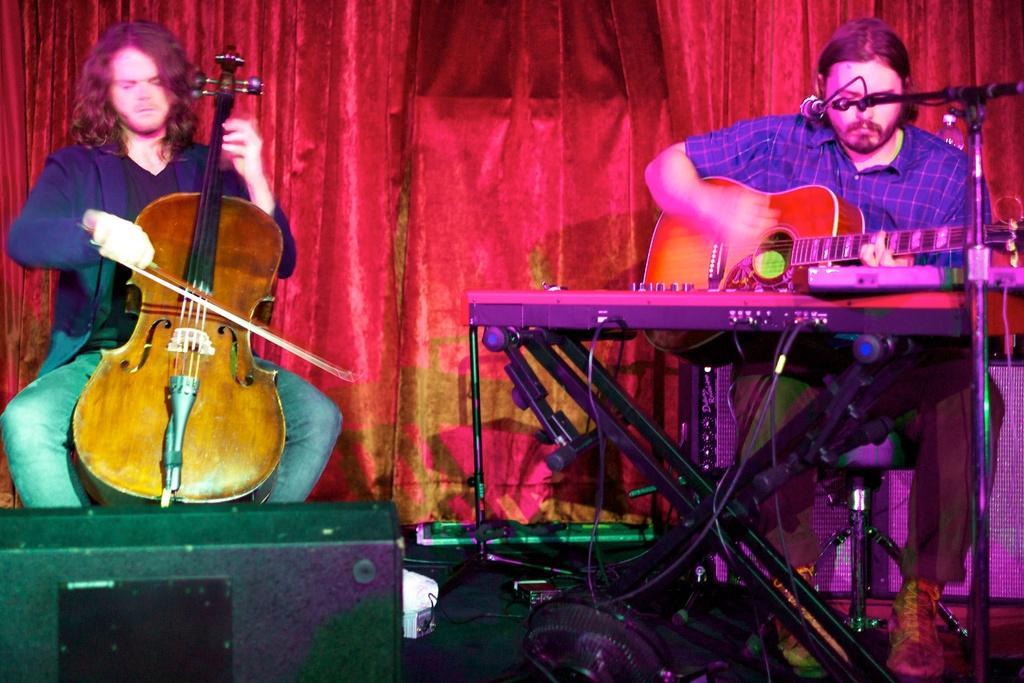Can you describe this image briefly? In this image I can see two people playing the musical instruments. 